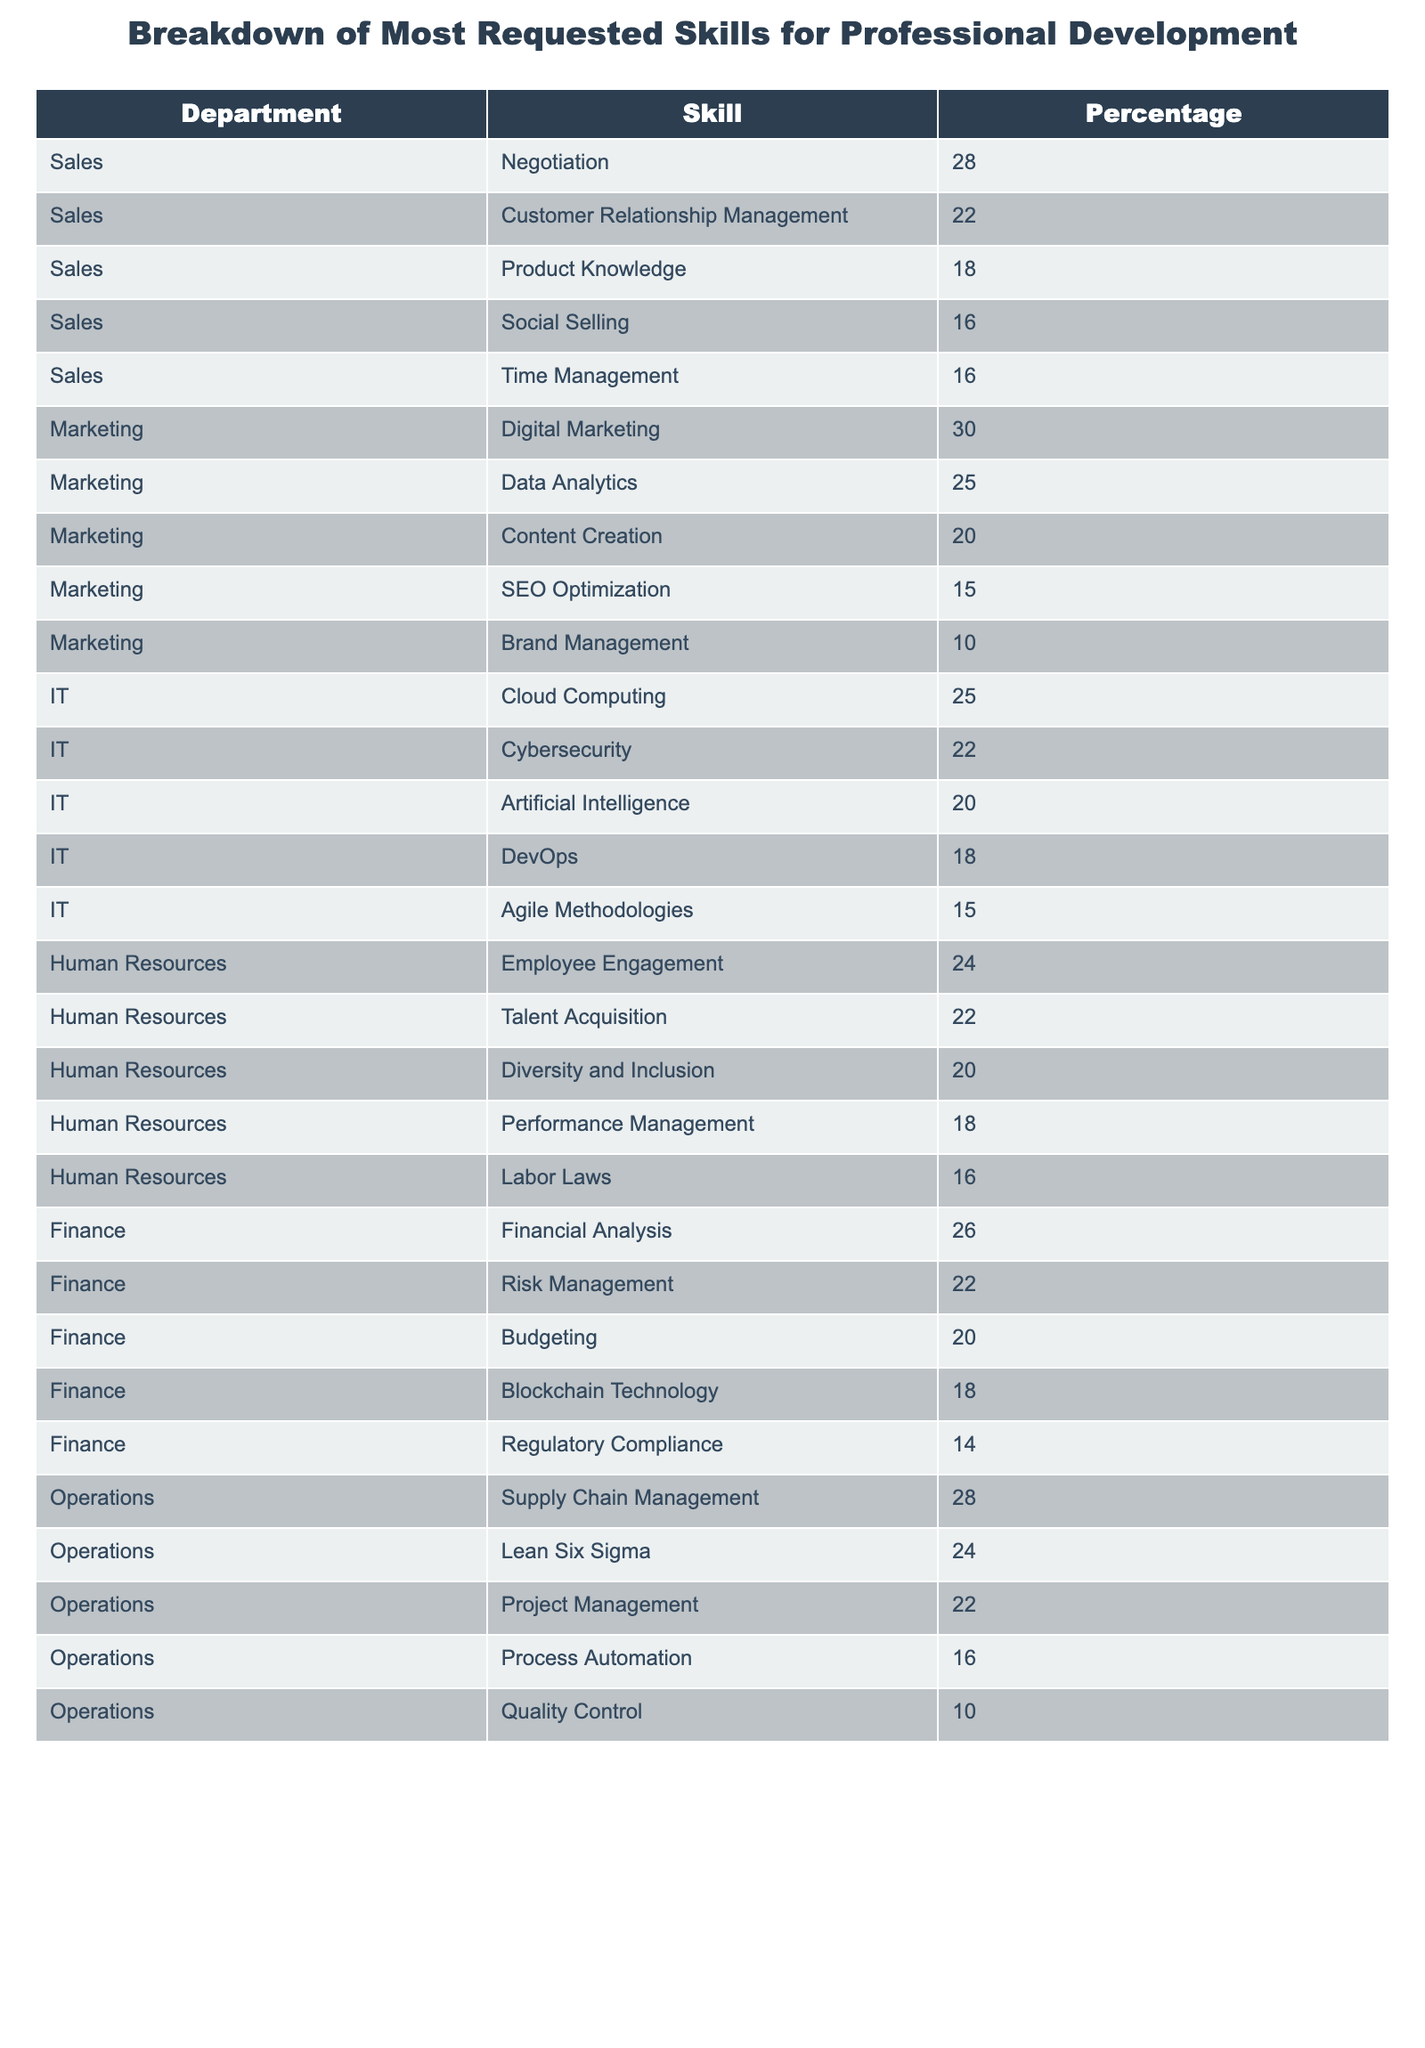What department has the highest requested skill in terms of percentage? The highest percentage skill is in the Marketing department for Digital Marketing at 30%.
Answer: Digital Marketing Which skill is requested the least across all departments? The skill with the lowest percentage is Regulatory Compliance in the Finance department at 14%.
Answer: Regulatory Compliance What percentage of employees in Sales requested skills related to Time Management and Social Selling combined? Time Management has a percentage of 16% and Social Selling has 16%; combining these gives 16 + 16 = 32%.
Answer: 32% Is Employee Engagement the most requested skill in Human Resources? Employee Engagement has a percentage of 24%, which is the highest in Human Resources, so yes, it is.
Answer: Yes What is the total percentage of skills requested for professional development in the IT department? The skills in IT are Cloud Computing (25%), Cybersecurity (22%), Artificial Intelligence (20%), DevOps (18%), and Agile Methodologies (15%). Adding these gives 25 + 22 + 20 + 18 + 15 = 100%.
Answer: 100% Which department has the highest combined percentage for skills related to Financial Analysis and Risk Management? The percentages are Financial Analysis (26%) and Risk Management (22%). Adding these gives 26 + 22 = 48%.
Answer: 48% How many skills in the Operations department have a percentage of 22 or higher? The skills with 22% or higher are Supply Chain Management (28%), Lean Six Sigma (24%), and Project Management (22%), totaling three skills.
Answer: 3 Which skill has the highest percentage in the Finance department and what is its percentage? The highest percentage skill in Finance is Financial Analysis at 26%.
Answer: Financial Analysis, 26% Is there a skill in the Marketing department that has the same percentage as a skill in the IT department? Yes, Data Analytics in Marketing (25%) matches Cloud Computing in IT (25%).
Answer: Yes Which department has the least percentage for Process Automation and what is it? The Operations department has Process Automation at 16%, which is the least for this skill.
Answer: Operations, 16% 